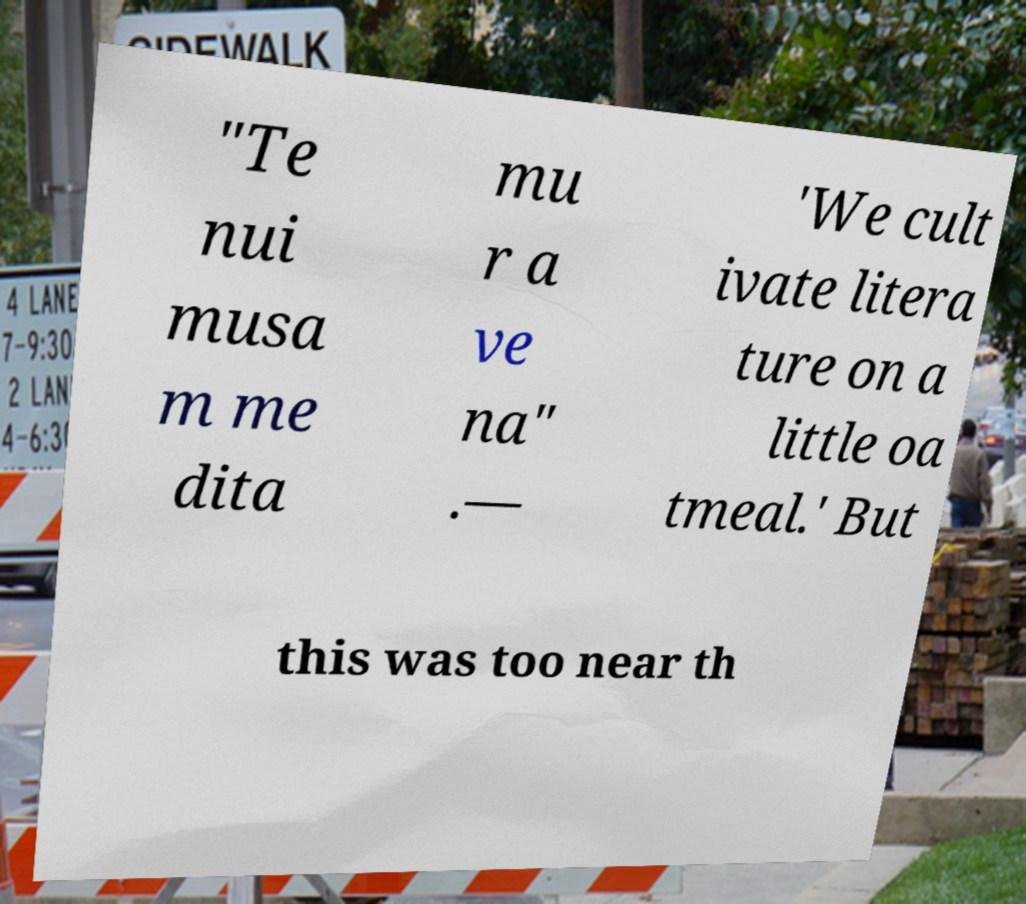For documentation purposes, I need the text within this image transcribed. Could you provide that? "Te nui musa m me dita mu r a ve na" .— 'We cult ivate litera ture on a little oa tmeal.' But this was too near th 